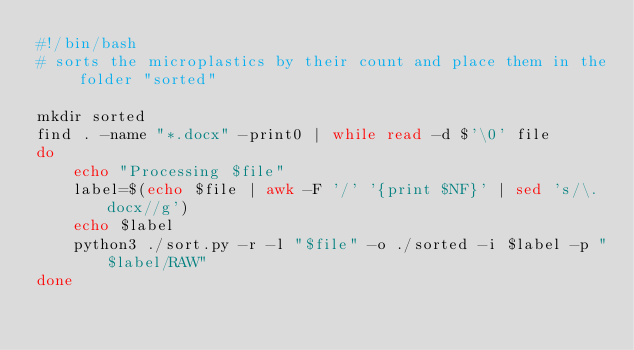Convert code to text. <code><loc_0><loc_0><loc_500><loc_500><_Bash_>#!/bin/bash
# sorts the microplastics by their count and place them in the folder "sorted"

mkdir sorted
find . -name "*.docx" -print0 | while read -d $'\0' file
do
    echo "Processing $file"
    label=$(echo $file | awk -F '/' '{print $NF}' | sed 's/\.docx//g')
    echo $label
    python3 ./sort.py -r -l "$file" -o ./sorted -i $label -p "$label/RAW"
done
</code> 